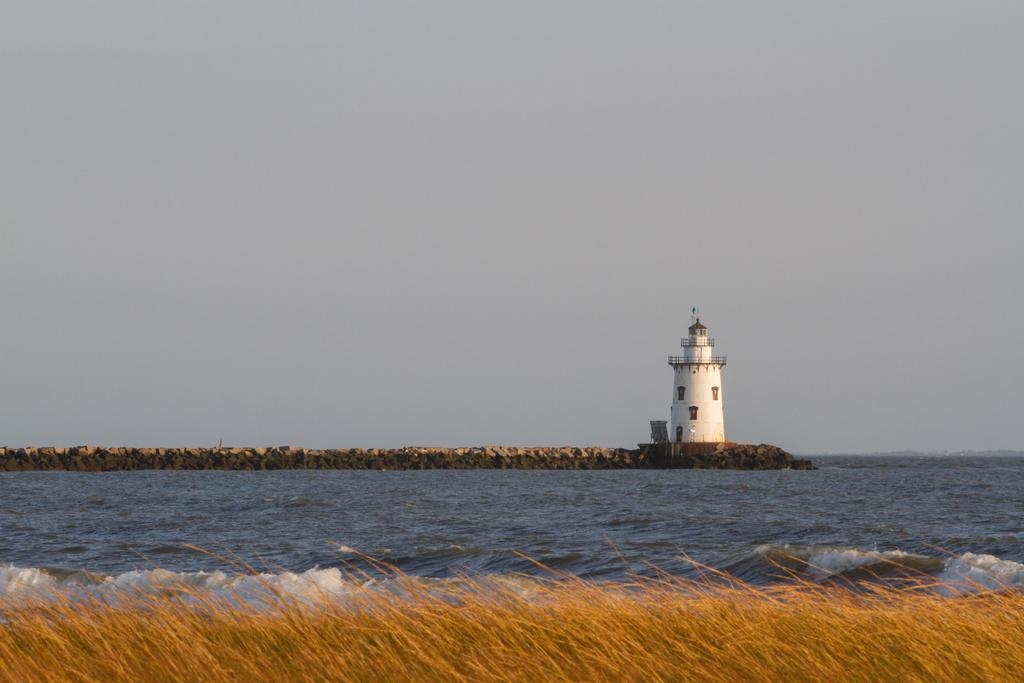What type of terrain is at the bottom of the image? There is grass at the bottom of the image. What natural feature is in the center of the image? There is a river in the center of the image. What structures can be seen in the background of the image? There is a tower and a wall in the background of the image. What is visible at the top of the image? The sky is visible at the top of the image. Is there a library present in the image? There is no mention of a library in the provided facts, so it cannot be determined if one is present in the image. Does the existence of the river in the image prove the existence of life on other planets? The presence of a river in the image does not provide any information about the existence of life on other planets; it is simply a natural feature in the image. 